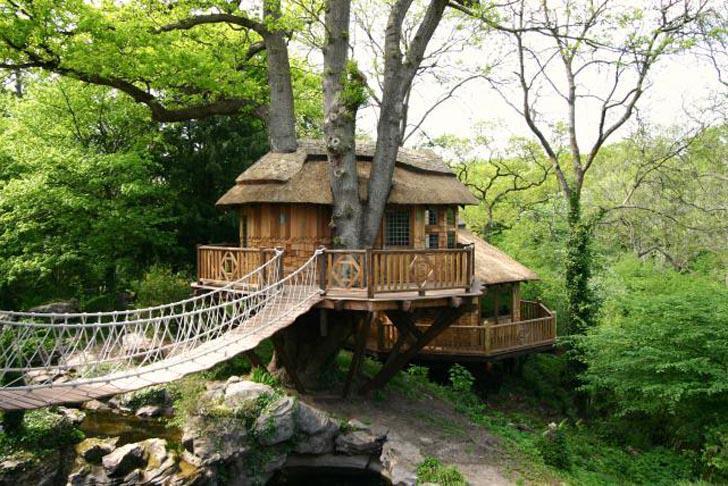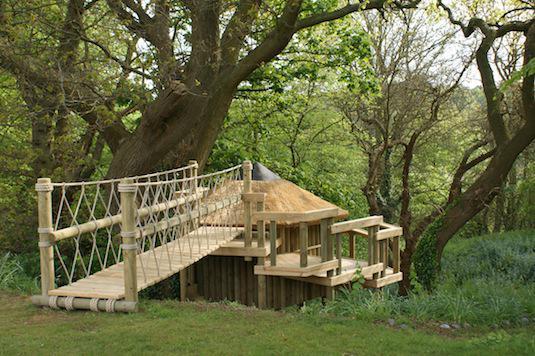The first image is the image on the left, the second image is the image on the right. Given the left and right images, does the statement "A rope walkway leads from the lower left to an elevated treehouse surrounded by a deck with railing." hold true? Answer yes or no. Yes. The first image is the image on the left, the second image is the image on the right. For the images displayed, is the sentence "there is a tree house with a bridge leading to it, in front of the house there are two tree trunks and there is one trunk behind" factually correct? Answer yes or no. Yes. 